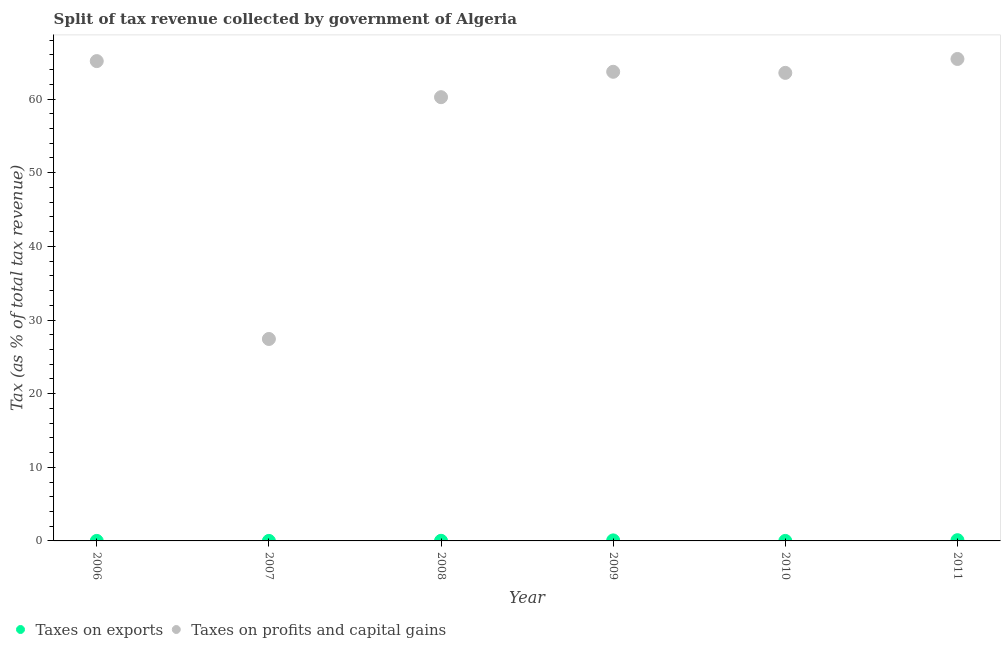Is the number of dotlines equal to the number of legend labels?
Provide a succinct answer. Yes. What is the percentage of revenue obtained from taxes on profits and capital gains in 2010?
Provide a short and direct response. 63.56. Across all years, what is the maximum percentage of revenue obtained from taxes on exports?
Your answer should be compact. 0.1. Across all years, what is the minimum percentage of revenue obtained from taxes on exports?
Make the answer very short. 0. In which year was the percentage of revenue obtained from taxes on exports minimum?
Provide a succinct answer. 2006. What is the total percentage of revenue obtained from taxes on profits and capital gains in the graph?
Keep it short and to the point. 345.55. What is the difference between the percentage of revenue obtained from taxes on profits and capital gains in 2008 and that in 2011?
Offer a very short reply. -5.19. What is the difference between the percentage of revenue obtained from taxes on profits and capital gains in 2010 and the percentage of revenue obtained from taxes on exports in 2008?
Keep it short and to the point. 63.54. What is the average percentage of revenue obtained from taxes on profits and capital gains per year?
Keep it short and to the point. 57.59. In the year 2009, what is the difference between the percentage of revenue obtained from taxes on exports and percentage of revenue obtained from taxes on profits and capital gains?
Your answer should be compact. -63.63. In how many years, is the percentage of revenue obtained from taxes on exports greater than 30 %?
Your response must be concise. 0. What is the ratio of the percentage of revenue obtained from taxes on profits and capital gains in 2008 to that in 2010?
Provide a succinct answer. 0.95. Is the percentage of revenue obtained from taxes on exports in 2007 less than that in 2009?
Give a very brief answer. Yes. Is the difference between the percentage of revenue obtained from taxes on exports in 2006 and 2008 greater than the difference between the percentage of revenue obtained from taxes on profits and capital gains in 2006 and 2008?
Provide a short and direct response. No. What is the difference between the highest and the second highest percentage of revenue obtained from taxes on exports?
Your response must be concise. 0.03. What is the difference between the highest and the lowest percentage of revenue obtained from taxes on exports?
Your answer should be compact. 0.1. In how many years, is the percentage of revenue obtained from taxes on exports greater than the average percentage of revenue obtained from taxes on exports taken over all years?
Offer a very short reply. 2. Does the percentage of revenue obtained from taxes on exports monotonically increase over the years?
Keep it short and to the point. No. Is the percentage of revenue obtained from taxes on exports strictly less than the percentage of revenue obtained from taxes on profits and capital gains over the years?
Give a very brief answer. Yes. What is the difference between two consecutive major ticks on the Y-axis?
Keep it short and to the point. 10. Are the values on the major ticks of Y-axis written in scientific E-notation?
Make the answer very short. No. Does the graph contain any zero values?
Offer a very short reply. No. Does the graph contain grids?
Provide a short and direct response. No. Where does the legend appear in the graph?
Ensure brevity in your answer.  Bottom left. How many legend labels are there?
Give a very brief answer. 2. What is the title of the graph?
Keep it short and to the point. Split of tax revenue collected by government of Algeria. What is the label or title of the Y-axis?
Your answer should be compact. Tax (as % of total tax revenue). What is the Tax (as % of total tax revenue) in Taxes on exports in 2006?
Offer a terse response. 0. What is the Tax (as % of total tax revenue) in Taxes on profits and capital gains in 2006?
Your answer should be compact. 65.16. What is the Tax (as % of total tax revenue) in Taxes on exports in 2007?
Offer a terse response. 0. What is the Tax (as % of total tax revenue) in Taxes on profits and capital gains in 2007?
Ensure brevity in your answer.  27.42. What is the Tax (as % of total tax revenue) of Taxes on exports in 2008?
Offer a very short reply. 0.02. What is the Tax (as % of total tax revenue) of Taxes on profits and capital gains in 2008?
Make the answer very short. 60.26. What is the Tax (as % of total tax revenue) of Taxes on exports in 2009?
Offer a terse response. 0.07. What is the Tax (as % of total tax revenue) in Taxes on profits and capital gains in 2009?
Provide a succinct answer. 63.71. What is the Tax (as % of total tax revenue) of Taxes on exports in 2010?
Provide a succinct answer. 0. What is the Tax (as % of total tax revenue) in Taxes on profits and capital gains in 2010?
Offer a very short reply. 63.56. What is the Tax (as % of total tax revenue) of Taxes on exports in 2011?
Your response must be concise. 0.1. What is the Tax (as % of total tax revenue) in Taxes on profits and capital gains in 2011?
Offer a terse response. 65.45. Across all years, what is the maximum Tax (as % of total tax revenue) of Taxes on exports?
Provide a short and direct response. 0.1. Across all years, what is the maximum Tax (as % of total tax revenue) in Taxes on profits and capital gains?
Provide a succinct answer. 65.45. Across all years, what is the minimum Tax (as % of total tax revenue) in Taxes on exports?
Offer a very short reply. 0. Across all years, what is the minimum Tax (as % of total tax revenue) in Taxes on profits and capital gains?
Your response must be concise. 27.42. What is the total Tax (as % of total tax revenue) in Taxes on exports in the graph?
Your response must be concise. 0.19. What is the total Tax (as % of total tax revenue) of Taxes on profits and capital gains in the graph?
Your answer should be very brief. 345.55. What is the difference between the Tax (as % of total tax revenue) in Taxes on exports in 2006 and that in 2007?
Give a very brief answer. -0. What is the difference between the Tax (as % of total tax revenue) of Taxes on profits and capital gains in 2006 and that in 2007?
Keep it short and to the point. 37.74. What is the difference between the Tax (as % of total tax revenue) in Taxes on exports in 2006 and that in 2008?
Offer a very short reply. -0.01. What is the difference between the Tax (as % of total tax revenue) in Taxes on profits and capital gains in 2006 and that in 2008?
Keep it short and to the point. 4.9. What is the difference between the Tax (as % of total tax revenue) in Taxes on exports in 2006 and that in 2009?
Ensure brevity in your answer.  -0.07. What is the difference between the Tax (as % of total tax revenue) in Taxes on profits and capital gains in 2006 and that in 2009?
Offer a terse response. 1.45. What is the difference between the Tax (as % of total tax revenue) in Taxes on exports in 2006 and that in 2010?
Offer a terse response. -0. What is the difference between the Tax (as % of total tax revenue) in Taxes on profits and capital gains in 2006 and that in 2010?
Offer a terse response. 1.6. What is the difference between the Tax (as % of total tax revenue) of Taxes on exports in 2006 and that in 2011?
Make the answer very short. -0.1. What is the difference between the Tax (as % of total tax revenue) in Taxes on profits and capital gains in 2006 and that in 2011?
Keep it short and to the point. -0.29. What is the difference between the Tax (as % of total tax revenue) of Taxes on exports in 2007 and that in 2008?
Keep it short and to the point. -0.01. What is the difference between the Tax (as % of total tax revenue) of Taxes on profits and capital gains in 2007 and that in 2008?
Ensure brevity in your answer.  -32.84. What is the difference between the Tax (as % of total tax revenue) of Taxes on exports in 2007 and that in 2009?
Your response must be concise. -0.07. What is the difference between the Tax (as % of total tax revenue) in Taxes on profits and capital gains in 2007 and that in 2009?
Give a very brief answer. -36.28. What is the difference between the Tax (as % of total tax revenue) of Taxes on exports in 2007 and that in 2010?
Offer a very short reply. 0. What is the difference between the Tax (as % of total tax revenue) of Taxes on profits and capital gains in 2007 and that in 2010?
Offer a terse response. -36.14. What is the difference between the Tax (as % of total tax revenue) of Taxes on exports in 2007 and that in 2011?
Make the answer very short. -0.1. What is the difference between the Tax (as % of total tax revenue) of Taxes on profits and capital gains in 2007 and that in 2011?
Your answer should be very brief. -38.02. What is the difference between the Tax (as % of total tax revenue) of Taxes on exports in 2008 and that in 2009?
Offer a very short reply. -0.06. What is the difference between the Tax (as % of total tax revenue) in Taxes on profits and capital gains in 2008 and that in 2009?
Your answer should be compact. -3.45. What is the difference between the Tax (as % of total tax revenue) of Taxes on exports in 2008 and that in 2010?
Ensure brevity in your answer.  0.01. What is the difference between the Tax (as % of total tax revenue) in Taxes on profits and capital gains in 2008 and that in 2010?
Your answer should be very brief. -3.3. What is the difference between the Tax (as % of total tax revenue) of Taxes on exports in 2008 and that in 2011?
Ensure brevity in your answer.  -0.08. What is the difference between the Tax (as % of total tax revenue) in Taxes on profits and capital gains in 2008 and that in 2011?
Offer a very short reply. -5.19. What is the difference between the Tax (as % of total tax revenue) of Taxes on exports in 2009 and that in 2010?
Offer a terse response. 0.07. What is the difference between the Tax (as % of total tax revenue) in Taxes on profits and capital gains in 2009 and that in 2010?
Your answer should be very brief. 0.15. What is the difference between the Tax (as % of total tax revenue) in Taxes on exports in 2009 and that in 2011?
Your answer should be compact. -0.03. What is the difference between the Tax (as % of total tax revenue) of Taxes on profits and capital gains in 2009 and that in 2011?
Ensure brevity in your answer.  -1.74. What is the difference between the Tax (as % of total tax revenue) of Taxes on exports in 2010 and that in 2011?
Give a very brief answer. -0.1. What is the difference between the Tax (as % of total tax revenue) in Taxes on profits and capital gains in 2010 and that in 2011?
Your response must be concise. -1.89. What is the difference between the Tax (as % of total tax revenue) in Taxes on exports in 2006 and the Tax (as % of total tax revenue) in Taxes on profits and capital gains in 2007?
Give a very brief answer. -27.42. What is the difference between the Tax (as % of total tax revenue) in Taxes on exports in 2006 and the Tax (as % of total tax revenue) in Taxes on profits and capital gains in 2008?
Your answer should be compact. -60.26. What is the difference between the Tax (as % of total tax revenue) in Taxes on exports in 2006 and the Tax (as % of total tax revenue) in Taxes on profits and capital gains in 2009?
Offer a terse response. -63.71. What is the difference between the Tax (as % of total tax revenue) of Taxes on exports in 2006 and the Tax (as % of total tax revenue) of Taxes on profits and capital gains in 2010?
Your answer should be very brief. -63.56. What is the difference between the Tax (as % of total tax revenue) of Taxes on exports in 2006 and the Tax (as % of total tax revenue) of Taxes on profits and capital gains in 2011?
Keep it short and to the point. -65.45. What is the difference between the Tax (as % of total tax revenue) of Taxes on exports in 2007 and the Tax (as % of total tax revenue) of Taxes on profits and capital gains in 2008?
Ensure brevity in your answer.  -60.26. What is the difference between the Tax (as % of total tax revenue) of Taxes on exports in 2007 and the Tax (as % of total tax revenue) of Taxes on profits and capital gains in 2009?
Provide a short and direct response. -63.7. What is the difference between the Tax (as % of total tax revenue) in Taxes on exports in 2007 and the Tax (as % of total tax revenue) in Taxes on profits and capital gains in 2010?
Your response must be concise. -63.56. What is the difference between the Tax (as % of total tax revenue) in Taxes on exports in 2007 and the Tax (as % of total tax revenue) in Taxes on profits and capital gains in 2011?
Make the answer very short. -65.44. What is the difference between the Tax (as % of total tax revenue) in Taxes on exports in 2008 and the Tax (as % of total tax revenue) in Taxes on profits and capital gains in 2009?
Make the answer very short. -63.69. What is the difference between the Tax (as % of total tax revenue) of Taxes on exports in 2008 and the Tax (as % of total tax revenue) of Taxes on profits and capital gains in 2010?
Offer a very short reply. -63.54. What is the difference between the Tax (as % of total tax revenue) of Taxes on exports in 2008 and the Tax (as % of total tax revenue) of Taxes on profits and capital gains in 2011?
Ensure brevity in your answer.  -65.43. What is the difference between the Tax (as % of total tax revenue) in Taxes on exports in 2009 and the Tax (as % of total tax revenue) in Taxes on profits and capital gains in 2010?
Your answer should be very brief. -63.49. What is the difference between the Tax (as % of total tax revenue) in Taxes on exports in 2009 and the Tax (as % of total tax revenue) in Taxes on profits and capital gains in 2011?
Offer a terse response. -65.38. What is the difference between the Tax (as % of total tax revenue) of Taxes on exports in 2010 and the Tax (as % of total tax revenue) of Taxes on profits and capital gains in 2011?
Keep it short and to the point. -65.45. What is the average Tax (as % of total tax revenue) of Taxes on exports per year?
Your answer should be compact. 0.03. What is the average Tax (as % of total tax revenue) in Taxes on profits and capital gains per year?
Your answer should be compact. 57.59. In the year 2006, what is the difference between the Tax (as % of total tax revenue) of Taxes on exports and Tax (as % of total tax revenue) of Taxes on profits and capital gains?
Offer a very short reply. -65.16. In the year 2007, what is the difference between the Tax (as % of total tax revenue) in Taxes on exports and Tax (as % of total tax revenue) in Taxes on profits and capital gains?
Offer a very short reply. -27.42. In the year 2008, what is the difference between the Tax (as % of total tax revenue) of Taxes on exports and Tax (as % of total tax revenue) of Taxes on profits and capital gains?
Make the answer very short. -60.24. In the year 2009, what is the difference between the Tax (as % of total tax revenue) in Taxes on exports and Tax (as % of total tax revenue) in Taxes on profits and capital gains?
Make the answer very short. -63.63. In the year 2010, what is the difference between the Tax (as % of total tax revenue) of Taxes on exports and Tax (as % of total tax revenue) of Taxes on profits and capital gains?
Your response must be concise. -63.56. In the year 2011, what is the difference between the Tax (as % of total tax revenue) of Taxes on exports and Tax (as % of total tax revenue) of Taxes on profits and capital gains?
Ensure brevity in your answer.  -65.35. What is the ratio of the Tax (as % of total tax revenue) of Taxes on exports in 2006 to that in 2007?
Offer a terse response. 0.25. What is the ratio of the Tax (as % of total tax revenue) of Taxes on profits and capital gains in 2006 to that in 2007?
Provide a succinct answer. 2.38. What is the ratio of the Tax (as % of total tax revenue) of Taxes on exports in 2006 to that in 2008?
Provide a succinct answer. 0.04. What is the ratio of the Tax (as % of total tax revenue) in Taxes on profits and capital gains in 2006 to that in 2008?
Offer a terse response. 1.08. What is the ratio of the Tax (as % of total tax revenue) of Taxes on exports in 2006 to that in 2009?
Make the answer very short. 0.01. What is the ratio of the Tax (as % of total tax revenue) in Taxes on profits and capital gains in 2006 to that in 2009?
Offer a very short reply. 1.02. What is the ratio of the Tax (as % of total tax revenue) in Taxes on exports in 2006 to that in 2010?
Keep it short and to the point. 0.79. What is the ratio of the Tax (as % of total tax revenue) of Taxes on profits and capital gains in 2006 to that in 2010?
Provide a short and direct response. 1.03. What is the ratio of the Tax (as % of total tax revenue) in Taxes on exports in 2006 to that in 2011?
Your answer should be compact. 0.01. What is the ratio of the Tax (as % of total tax revenue) in Taxes on profits and capital gains in 2006 to that in 2011?
Provide a short and direct response. 1. What is the ratio of the Tax (as % of total tax revenue) of Taxes on exports in 2007 to that in 2008?
Your answer should be compact. 0.15. What is the ratio of the Tax (as % of total tax revenue) of Taxes on profits and capital gains in 2007 to that in 2008?
Provide a short and direct response. 0.46. What is the ratio of the Tax (as % of total tax revenue) in Taxes on exports in 2007 to that in 2009?
Make the answer very short. 0.03. What is the ratio of the Tax (as % of total tax revenue) of Taxes on profits and capital gains in 2007 to that in 2009?
Make the answer very short. 0.43. What is the ratio of the Tax (as % of total tax revenue) in Taxes on exports in 2007 to that in 2010?
Keep it short and to the point. 3.14. What is the ratio of the Tax (as % of total tax revenue) of Taxes on profits and capital gains in 2007 to that in 2010?
Your answer should be very brief. 0.43. What is the ratio of the Tax (as % of total tax revenue) in Taxes on exports in 2007 to that in 2011?
Ensure brevity in your answer.  0.02. What is the ratio of the Tax (as % of total tax revenue) of Taxes on profits and capital gains in 2007 to that in 2011?
Your answer should be very brief. 0.42. What is the ratio of the Tax (as % of total tax revenue) of Taxes on exports in 2008 to that in 2009?
Give a very brief answer. 0.22. What is the ratio of the Tax (as % of total tax revenue) in Taxes on profits and capital gains in 2008 to that in 2009?
Your answer should be compact. 0.95. What is the ratio of the Tax (as % of total tax revenue) of Taxes on exports in 2008 to that in 2010?
Ensure brevity in your answer.  21.19. What is the ratio of the Tax (as % of total tax revenue) of Taxes on profits and capital gains in 2008 to that in 2010?
Your answer should be very brief. 0.95. What is the ratio of the Tax (as % of total tax revenue) in Taxes on exports in 2008 to that in 2011?
Provide a succinct answer. 0.15. What is the ratio of the Tax (as % of total tax revenue) of Taxes on profits and capital gains in 2008 to that in 2011?
Your response must be concise. 0.92. What is the ratio of the Tax (as % of total tax revenue) of Taxes on exports in 2009 to that in 2010?
Make the answer very short. 97.89. What is the ratio of the Tax (as % of total tax revenue) of Taxes on exports in 2009 to that in 2011?
Ensure brevity in your answer.  0.72. What is the ratio of the Tax (as % of total tax revenue) of Taxes on profits and capital gains in 2009 to that in 2011?
Keep it short and to the point. 0.97. What is the ratio of the Tax (as % of total tax revenue) of Taxes on exports in 2010 to that in 2011?
Provide a short and direct response. 0.01. What is the ratio of the Tax (as % of total tax revenue) in Taxes on profits and capital gains in 2010 to that in 2011?
Your answer should be compact. 0.97. What is the difference between the highest and the second highest Tax (as % of total tax revenue) in Taxes on exports?
Ensure brevity in your answer.  0.03. What is the difference between the highest and the second highest Tax (as % of total tax revenue) of Taxes on profits and capital gains?
Provide a succinct answer. 0.29. What is the difference between the highest and the lowest Tax (as % of total tax revenue) in Taxes on exports?
Offer a terse response. 0.1. What is the difference between the highest and the lowest Tax (as % of total tax revenue) in Taxes on profits and capital gains?
Your response must be concise. 38.02. 